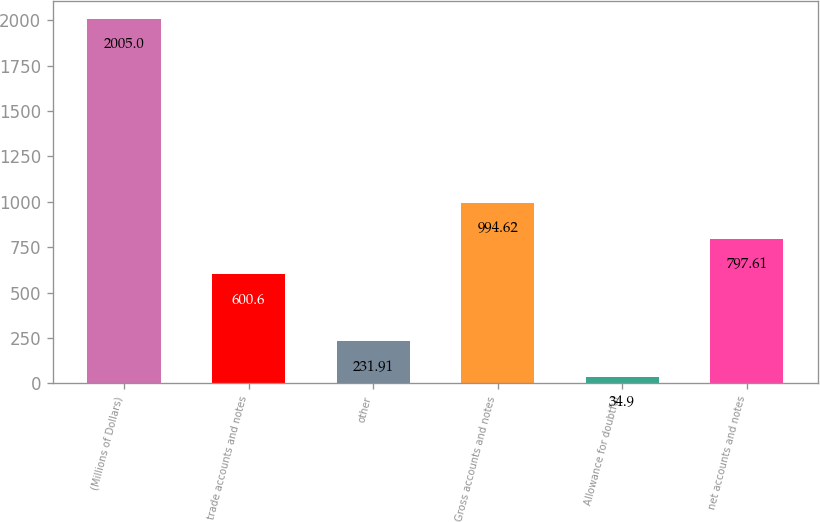Convert chart. <chart><loc_0><loc_0><loc_500><loc_500><bar_chart><fcel>(Millions of Dollars)<fcel>trade accounts and notes<fcel>other<fcel>Gross accounts and notes<fcel>Allowance for doubtful<fcel>net accounts and notes<nl><fcel>2005<fcel>600.6<fcel>231.91<fcel>994.62<fcel>34.9<fcel>797.61<nl></chart> 